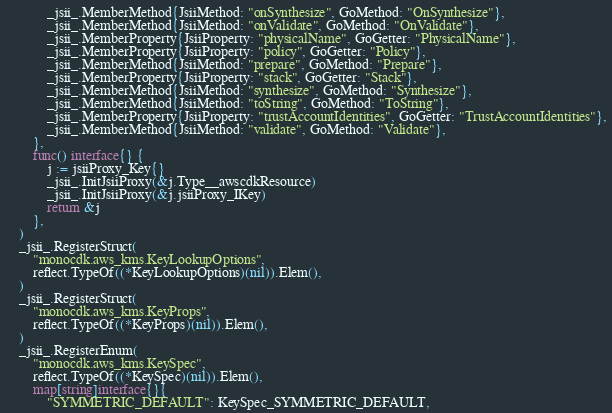Convert code to text. <code><loc_0><loc_0><loc_500><loc_500><_Go_>			_jsii_.MemberMethod{JsiiMethod: "onSynthesize", GoMethod: "OnSynthesize"},
			_jsii_.MemberMethod{JsiiMethod: "onValidate", GoMethod: "OnValidate"},
			_jsii_.MemberProperty{JsiiProperty: "physicalName", GoGetter: "PhysicalName"},
			_jsii_.MemberProperty{JsiiProperty: "policy", GoGetter: "Policy"},
			_jsii_.MemberMethod{JsiiMethod: "prepare", GoMethod: "Prepare"},
			_jsii_.MemberProperty{JsiiProperty: "stack", GoGetter: "Stack"},
			_jsii_.MemberMethod{JsiiMethod: "synthesize", GoMethod: "Synthesize"},
			_jsii_.MemberMethod{JsiiMethod: "toString", GoMethod: "ToString"},
			_jsii_.MemberProperty{JsiiProperty: "trustAccountIdentities", GoGetter: "TrustAccountIdentities"},
			_jsii_.MemberMethod{JsiiMethod: "validate", GoMethod: "Validate"},
		},
		func() interface{} {
			j := jsiiProxy_Key{}
			_jsii_.InitJsiiProxy(&j.Type__awscdkResource)
			_jsii_.InitJsiiProxy(&j.jsiiProxy_IKey)
			return &j
		},
	)
	_jsii_.RegisterStruct(
		"monocdk.aws_kms.KeyLookupOptions",
		reflect.TypeOf((*KeyLookupOptions)(nil)).Elem(),
	)
	_jsii_.RegisterStruct(
		"monocdk.aws_kms.KeyProps",
		reflect.TypeOf((*KeyProps)(nil)).Elem(),
	)
	_jsii_.RegisterEnum(
		"monocdk.aws_kms.KeySpec",
		reflect.TypeOf((*KeySpec)(nil)).Elem(),
		map[string]interface{}{
			"SYMMETRIC_DEFAULT": KeySpec_SYMMETRIC_DEFAULT,</code> 